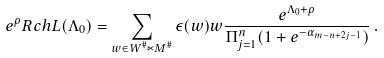Convert formula to latex. <formula><loc_0><loc_0><loc_500><loc_500>e ^ { \rho } R c h L ( \Lambda _ { 0 } ) = \sum _ { w \in W ^ { \# } \ltimes M ^ { \# } } \epsilon ( w ) w \frac { e ^ { \Lambda _ { 0 } + \rho } } { \Pi ^ { n } _ { j = 1 } ( 1 + e ^ { - \alpha _ { m - n + 2 j - 1 } } ) } \, .</formula> 